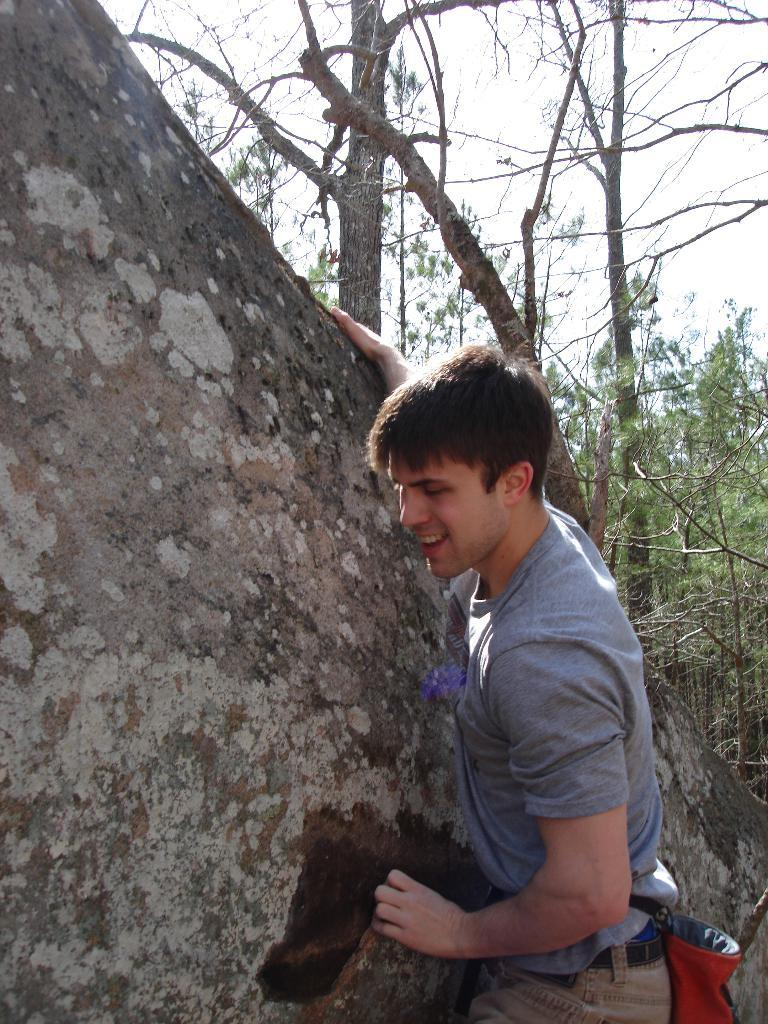Who is present in the image? There is a man in the image. What is the man wearing? The man is wearing a grey t-shirt. What can be seen in the background of the image? There are trees in the background of the image. What color or material is the brown object or area in the image? The brown object or area in the image is not described in detail, so we cannot determine its color or material. What type of insurance does the group in the image have? There is no group present in the image, and therefore no insurance information can be determined. 